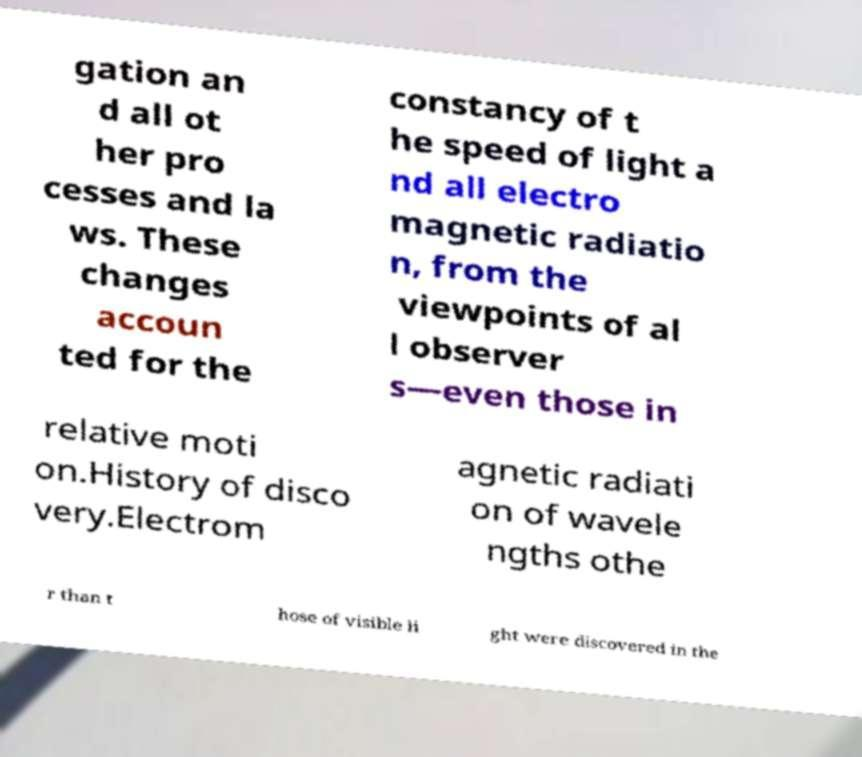There's text embedded in this image that I need extracted. Can you transcribe it verbatim? gation an d all ot her pro cesses and la ws. These changes accoun ted for the constancy of t he speed of light a nd all electro magnetic radiatio n, from the viewpoints of al l observer s—even those in relative moti on.History of disco very.Electrom agnetic radiati on of wavele ngths othe r than t hose of visible li ght were discovered in the 